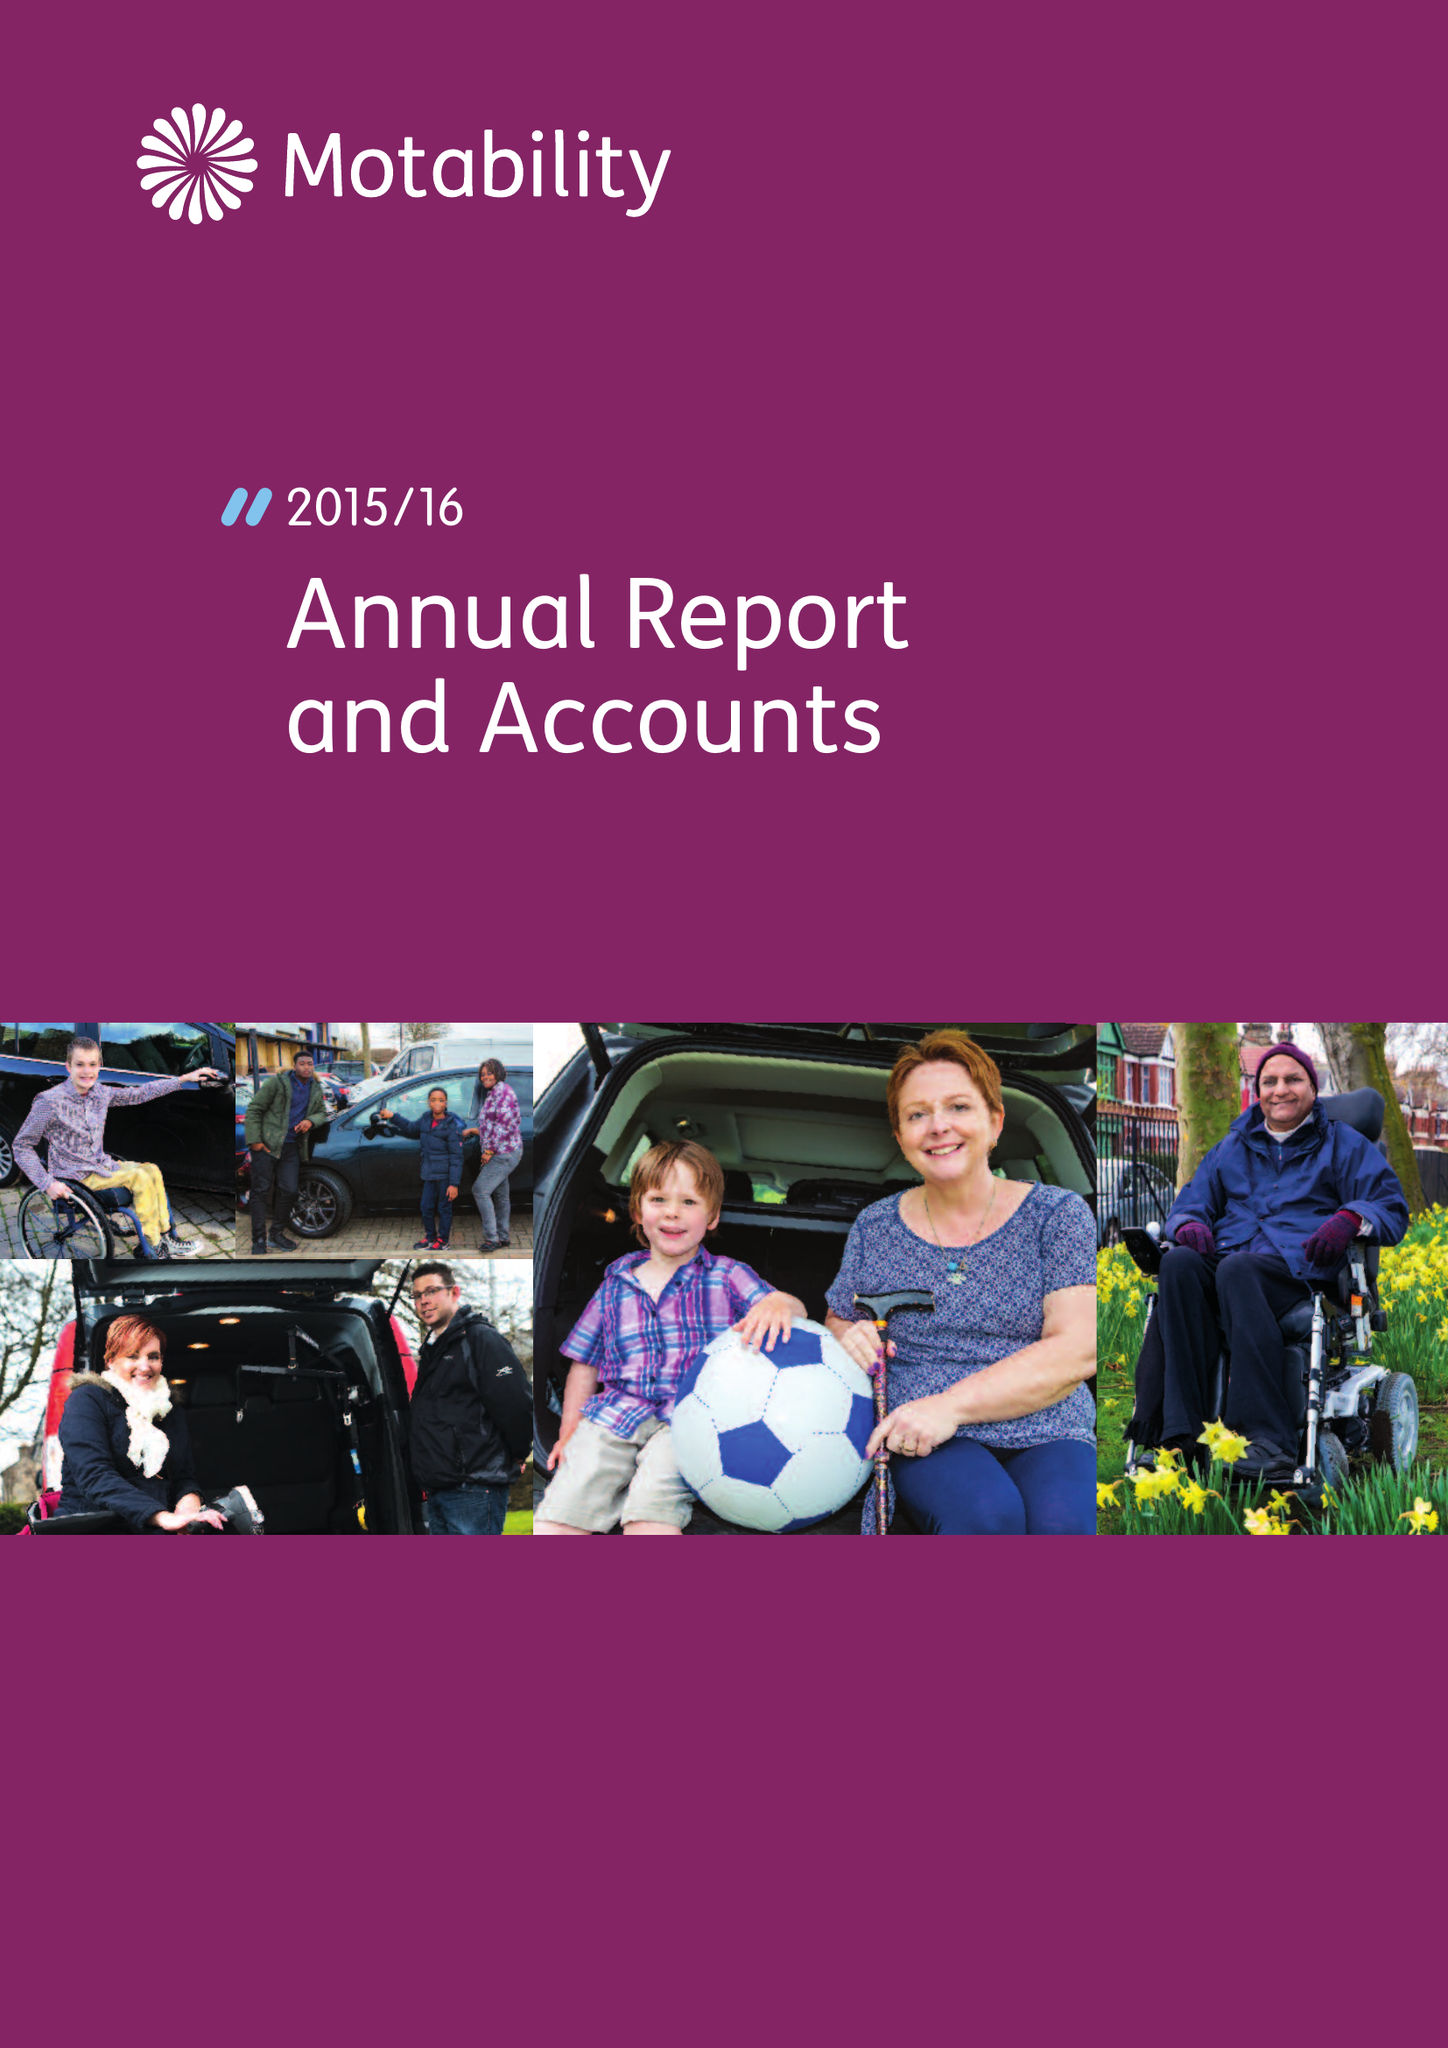What is the value for the income_annually_in_british_pounds?
Answer the question using a single word or phrase. 67133000.00 